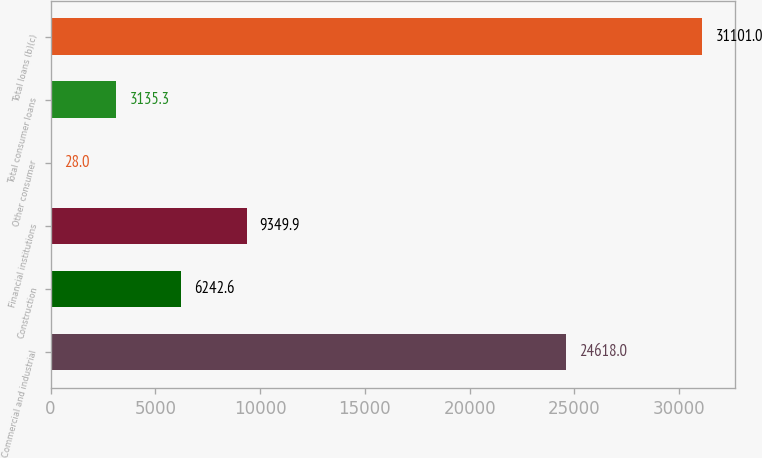Convert chart to OTSL. <chart><loc_0><loc_0><loc_500><loc_500><bar_chart><fcel>Commercial and industrial<fcel>Construction<fcel>Financial institutions<fcel>Other consumer<fcel>Total consumer loans<fcel>Total loans (b)(c)<nl><fcel>24618<fcel>6242.6<fcel>9349.9<fcel>28<fcel>3135.3<fcel>31101<nl></chart> 